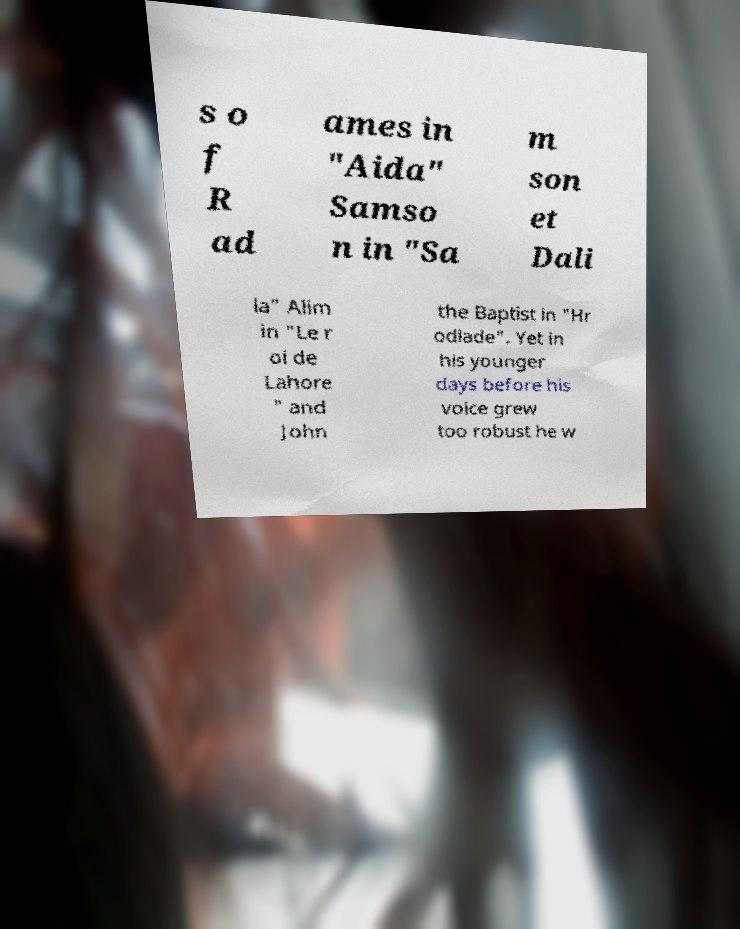Could you extract and type out the text from this image? s o f R ad ames in "Aida" Samso n in "Sa m son et Dali la" Alim in "Le r oi de Lahore " and John the Baptist in "Hr odiade". Yet in his younger days before his voice grew too robust he w 